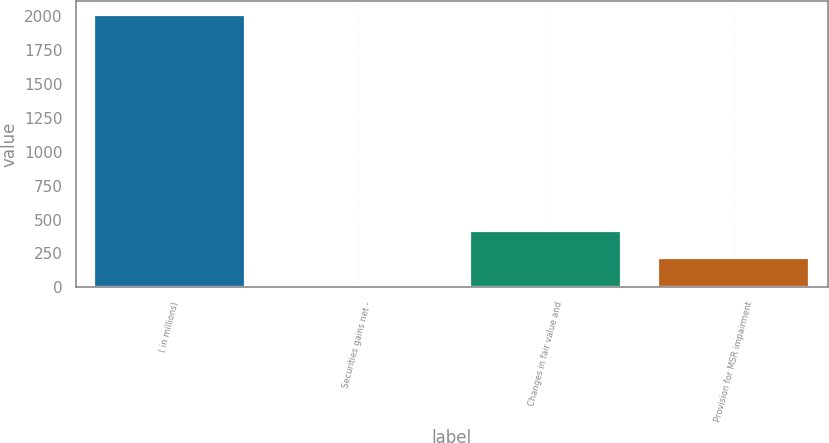Convert chart to OTSL. <chart><loc_0><loc_0><loc_500><loc_500><bar_chart><fcel>( in millions)<fcel>Securities gains net -<fcel>Changes in fair value and<fcel>Provision for MSR impairment<nl><fcel>2010<fcel>14<fcel>413.2<fcel>213.6<nl></chart> 